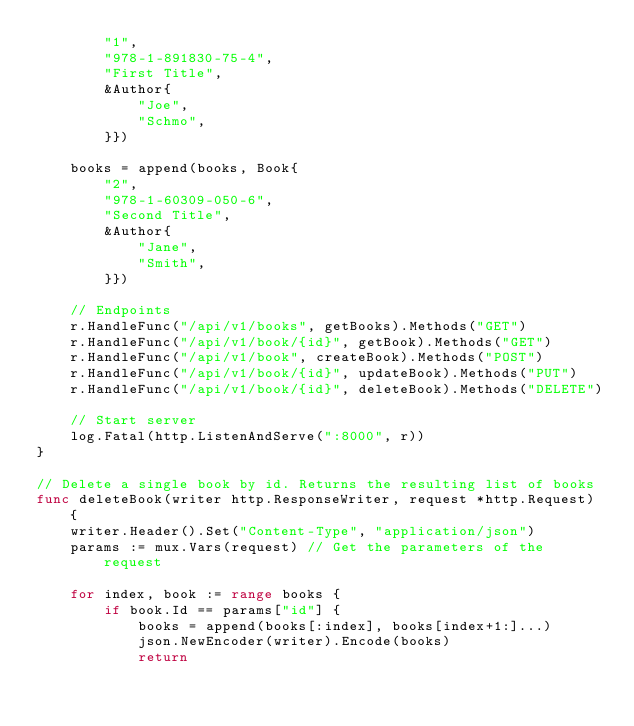Convert code to text. <code><loc_0><loc_0><loc_500><loc_500><_Go_>		"1",
		"978-1-891830-75-4",
		"First Title",
		&Author{
			"Joe",
			"Schmo",
		}})

	books = append(books, Book{
		"2",
		"978-1-60309-050-6",
		"Second Title",
		&Author{
			"Jane",
			"Smith",
		}})

	// Endpoints
	r.HandleFunc("/api/v1/books", getBooks).Methods("GET")
	r.HandleFunc("/api/v1/book/{id}", getBook).Methods("GET")
	r.HandleFunc("/api/v1/book", createBook).Methods("POST")
	r.HandleFunc("/api/v1/book/{id}", updateBook).Methods("PUT")
	r.HandleFunc("/api/v1/book/{id}", deleteBook).Methods("DELETE")

	// Start server
	log.Fatal(http.ListenAndServe(":8000", r))
}

// Delete a single book by id. Returns the resulting list of books
func deleteBook(writer http.ResponseWriter, request *http.Request) {
	writer.Header().Set("Content-Type", "application/json")
	params := mux.Vars(request) // Get the parameters of the request

	for index, book := range books {
		if book.Id == params["id"] {
			books = append(books[:index], books[index+1:]...)
			json.NewEncoder(writer).Encode(books)
			return</code> 